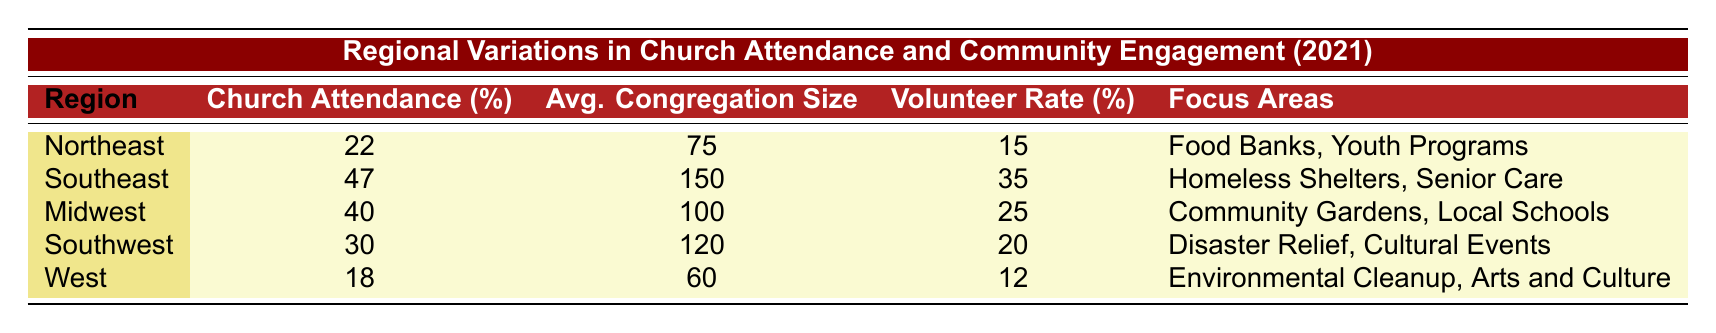What region has the highest church attendance percentage? The table shows that the Southeast region has the highest church attendance percentage at 47%.
Answer: Southeast What is the average congregation size in the Northeast? Referring to the table, the average congregation size in the Northeast is 75.
Answer: 75 Which region has the lowest volunteer rate? According to the table, the West region has the lowest volunteer rate at 12%.
Answer: West What is the sum of church attendance percentages of the Midwest and Southwest regions? The Midwest region has a church attendance percentage of 40% and the Southwest has 30%. Adding these together gives 40 + 30 = 70.
Answer: 70 Is the volunteer rate in the Southeast region higher than in the Northeast? The Southeast has a volunteer rate of 35%, while the Northeast has 15%. Since 35% is greater than 15%, the answer is yes.
Answer: Yes Which region focuses on food banks and youth programs? The table indicates that the Northeast region focuses on food banks and youth programs.
Answer: Northeast What is the average congregation size across all regions? To find the average congregation size, we add the sizes: 75 (Northeast) + 150 (Southeast) + 100 (Midwest) + 120 (Southwest) + 60 (West) = 605. There are 5 regions, so the average is 605/5 = 121.
Answer: 121 In which region is the volunteer rate higher than the average congregation size? The volunteer rates are 15% (Northeast), 35% (Southeast), 25% (Midwest), 20% (Southwest), and 12% (West). The average congregation sizes are 75, 150, 100, 120, and 60 respectively. Only the Southeast's volunteer rate (35%) exceeds its average congregation size (150), indicating it does not meet the criteria.
Answer: None How many focus areas are listed for the Midwest region? The Midwest region lists two focus areas: community gardens and local schools. Therefore, the answer is based on the count of focus areas given.
Answer: 2 Which region has community engagement focused on disaster relief? The Southwest region is identified as focusing on disaster relief among its community engagement efforts.
Answer: Southwest 